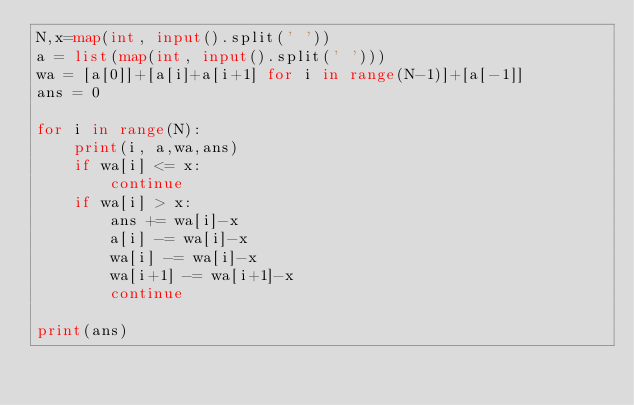Convert code to text. <code><loc_0><loc_0><loc_500><loc_500><_Python_>N,x=map(int, input().split(' '))
a = list(map(int, input().split(' ')))
wa = [a[0]]+[a[i]+a[i+1] for i in range(N-1)]+[a[-1]]
ans = 0

for i in range(N):
    print(i, a,wa,ans)
    if wa[i] <= x:
        continue
    if wa[i] > x:
        ans += wa[i]-x
        a[i] -= wa[i]-x
        wa[i] -= wa[i]-x
        wa[i+1] -= wa[i+1]-x
        continue

print(ans)</code> 